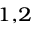<formula> <loc_0><loc_0><loc_500><loc_500>^ { 1 , 2 }</formula> 